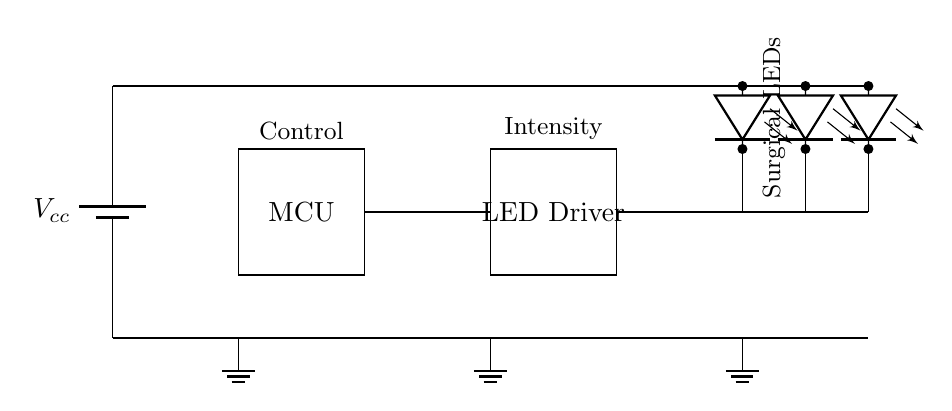What type of components are used in this circuit? The circuit includes a battery, a microcontroller (MCU), an LED driver, and multiple LEDs. These components are clearly labeled and outlined in the circuit diagram.
Answer: Battery, microcontroller, LED driver, LEDs What is the purpose of the microcontroller in this circuit? The microcontroller (MCU) is used to control the intensity of the LEDs, as indicated by its label and its connection to the LED driver. It acts as the brain of the illumination system, regulating the function of the LEDs based on user input or pre-defined settings.
Answer: Control intensity How many LEDs are present in this circuit? The circuit diagram shows three LEDs connected in parallel, as indicated by the three separate LED symbols grouped together and connected to the LED driver.
Answer: Three What is the role of the LED driver in this configuration? The LED driver is responsible for providing the necessary current and voltage to the LEDs for proper operation. It takes the input from the microcontroller and adjusts the output to ensure that the LEDs receive the right power to illuminate effectively. This is essential for achieving desired brightness and maintaining LED longevity.
Answer: Power regulation What is the ground reference point in this circuit? The ground reference points appear at the bottom of the battery, microcontroller, LED driver, and LED sections. Each component's ground is essential for completing the circuit and establishing a common voltage reference for the entire system.
Answer: At the bottom of each component What is the voltage source in this circuit and its position? The voltage source is represented by the battery labeled as Vcc, located at the left side of the circuit diagram. The battery supplies the necessary voltage to power all connected components.
Answer: Vcc 